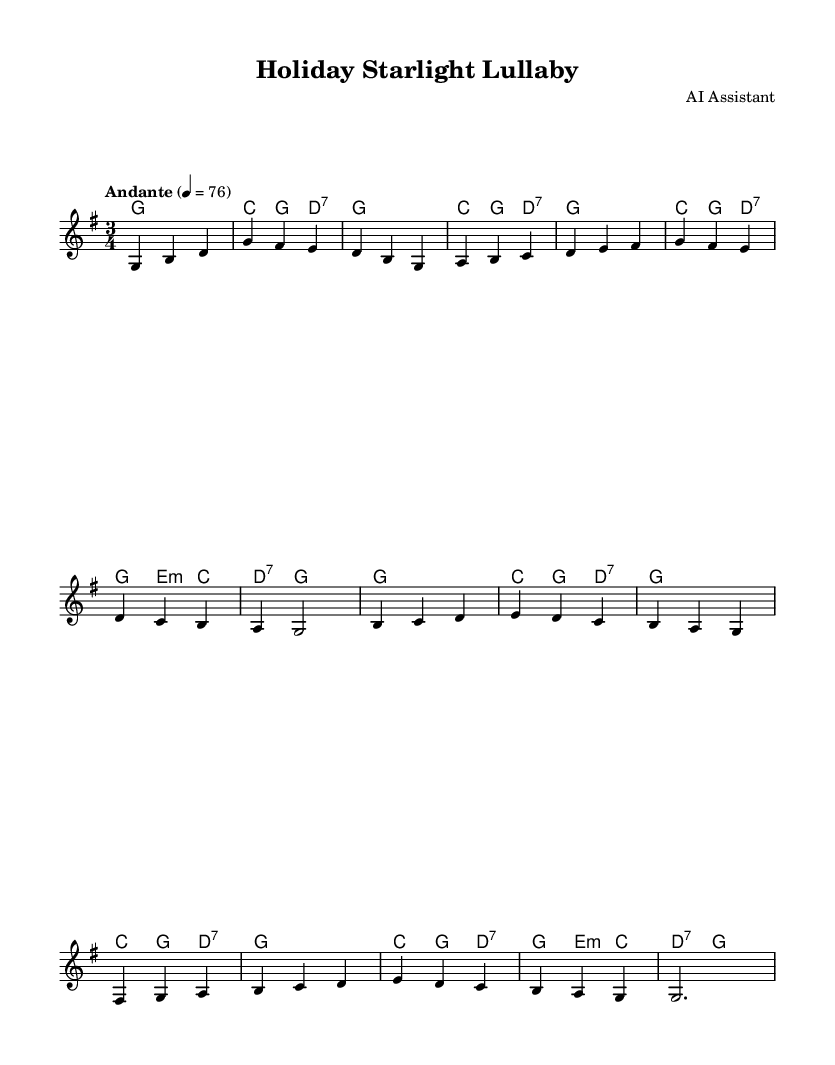What is the key signature of this music? The key signature is G major, which has one sharp (F#). This can be identified from the key signature indicated at the beginning of the sheet music.
Answer: G major What is the time signature of this music? The time signature is 3/4, which indicates three beats per measure and a quarter note gets one beat. This can be found at the beginning of the piece.
Answer: 3/4 What is the tempo marking for this piece? The tempo marking is "Andante", indicating a moderate tempo. The tempo is noted at the beginning of the sheet with a metronome marking of 76 beats per minute.
Answer: Andante Which chord follows the G major chord in the first measure? The chord that follows the G major chord in the first measure is C major. This can be seen in the harmony section where the chord progression shows a G chord followed by a C chord.
Answer: C major How many measures are in the melody? There are 16 measures in the melody. This can be counted by examining the melody line, noting each vertical bar that separates the measures.
Answer: 16 Which note is held as a half note in the last measure of the melody? The note held as a half note in the last measure of the melody is G. This is shown at the end of the melody part, where it is written as a whole note, indicating it is sustained for two beats.
Answer: G What type of music is this piece classified as? This piece is classified as a lullaby, which is a gentle and soothing type of music typically used for bedtime. The title itself, "Holiday Starlight Lullaby," suggests this style.
Answer: Lullaby 